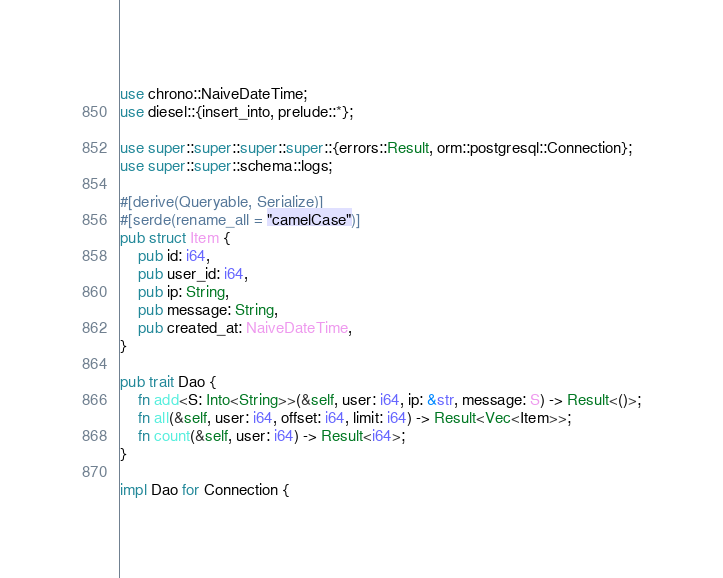<code> <loc_0><loc_0><loc_500><loc_500><_Rust_>use chrono::NaiveDateTime;
use diesel::{insert_into, prelude::*};

use super::super::super::super::{errors::Result, orm::postgresql::Connection};
use super::super::schema::logs;

#[derive(Queryable, Serialize)]
#[serde(rename_all = "camelCase")]
pub struct Item {
    pub id: i64,
    pub user_id: i64,
    pub ip: String,
    pub message: String,
    pub created_at: NaiveDateTime,
}

pub trait Dao {
    fn add<S: Into<String>>(&self, user: i64, ip: &str, message: S) -> Result<()>;
    fn all(&self, user: i64, offset: i64, limit: i64) -> Result<Vec<Item>>;
    fn count(&self, user: i64) -> Result<i64>;
}

impl Dao for Connection {</code> 